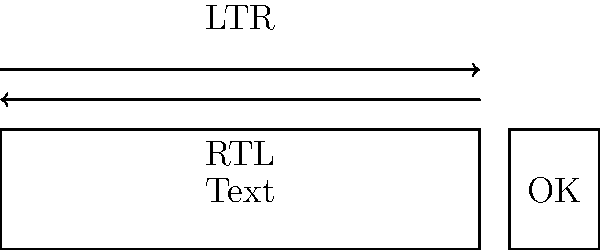In a multilingual software interface, text direction can vary between left-to-right (LTR) and right-to-left (RTL) languages. How should the alignment of text and graphical elements be adjusted to accommodate RTL languages compared to the LTR layout shown in the diagram? To accommodate right-to-left (RTL) languages in a software interface, several adjustments need to be made:

1. Text alignment: In RTL languages, text should be right-aligned instead of left-aligned.

2. Reading order: The flow of interface elements should be from right to left.

3. Mirroring layout: The entire interface layout should be mirrored horizontally.

4. Text box: The text input area should have its cursor aligned to the right side.

5. Buttons: Action buttons like "OK" should be moved to the left side of the text box.

6. Icons and symbols: Directional icons (e.g., arrows) should be flipped horizontally to match the RTL flow.

7. Numbers: Even in RTL languages, numbers are typically displayed left-to-right.

8. Bidirectional support: The interface should support mixed LTR and RTL content for languages that may include both (e.g., Arabic with English words).

9. Text overflow: Ensure that expanding text fields grow to the left instead of the right.

10. Testing: Thorough testing with native RTL language speakers is crucial to ensure proper alignment and natural flow.

By implementing these adjustments, the software interface will be properly aligned for RTL languages, ensuring a consistent user experience across different language markets.
Answer: Mirror layout horizontally, right-align text, move buttons to left, flip directional icons. 